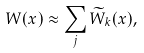<formula> <loc_0><loc_0><loc_500><loc_500>W ( x ) \approx \sum _ { j } \widetilde { W } _ { k } ( x ) ,</formula> 